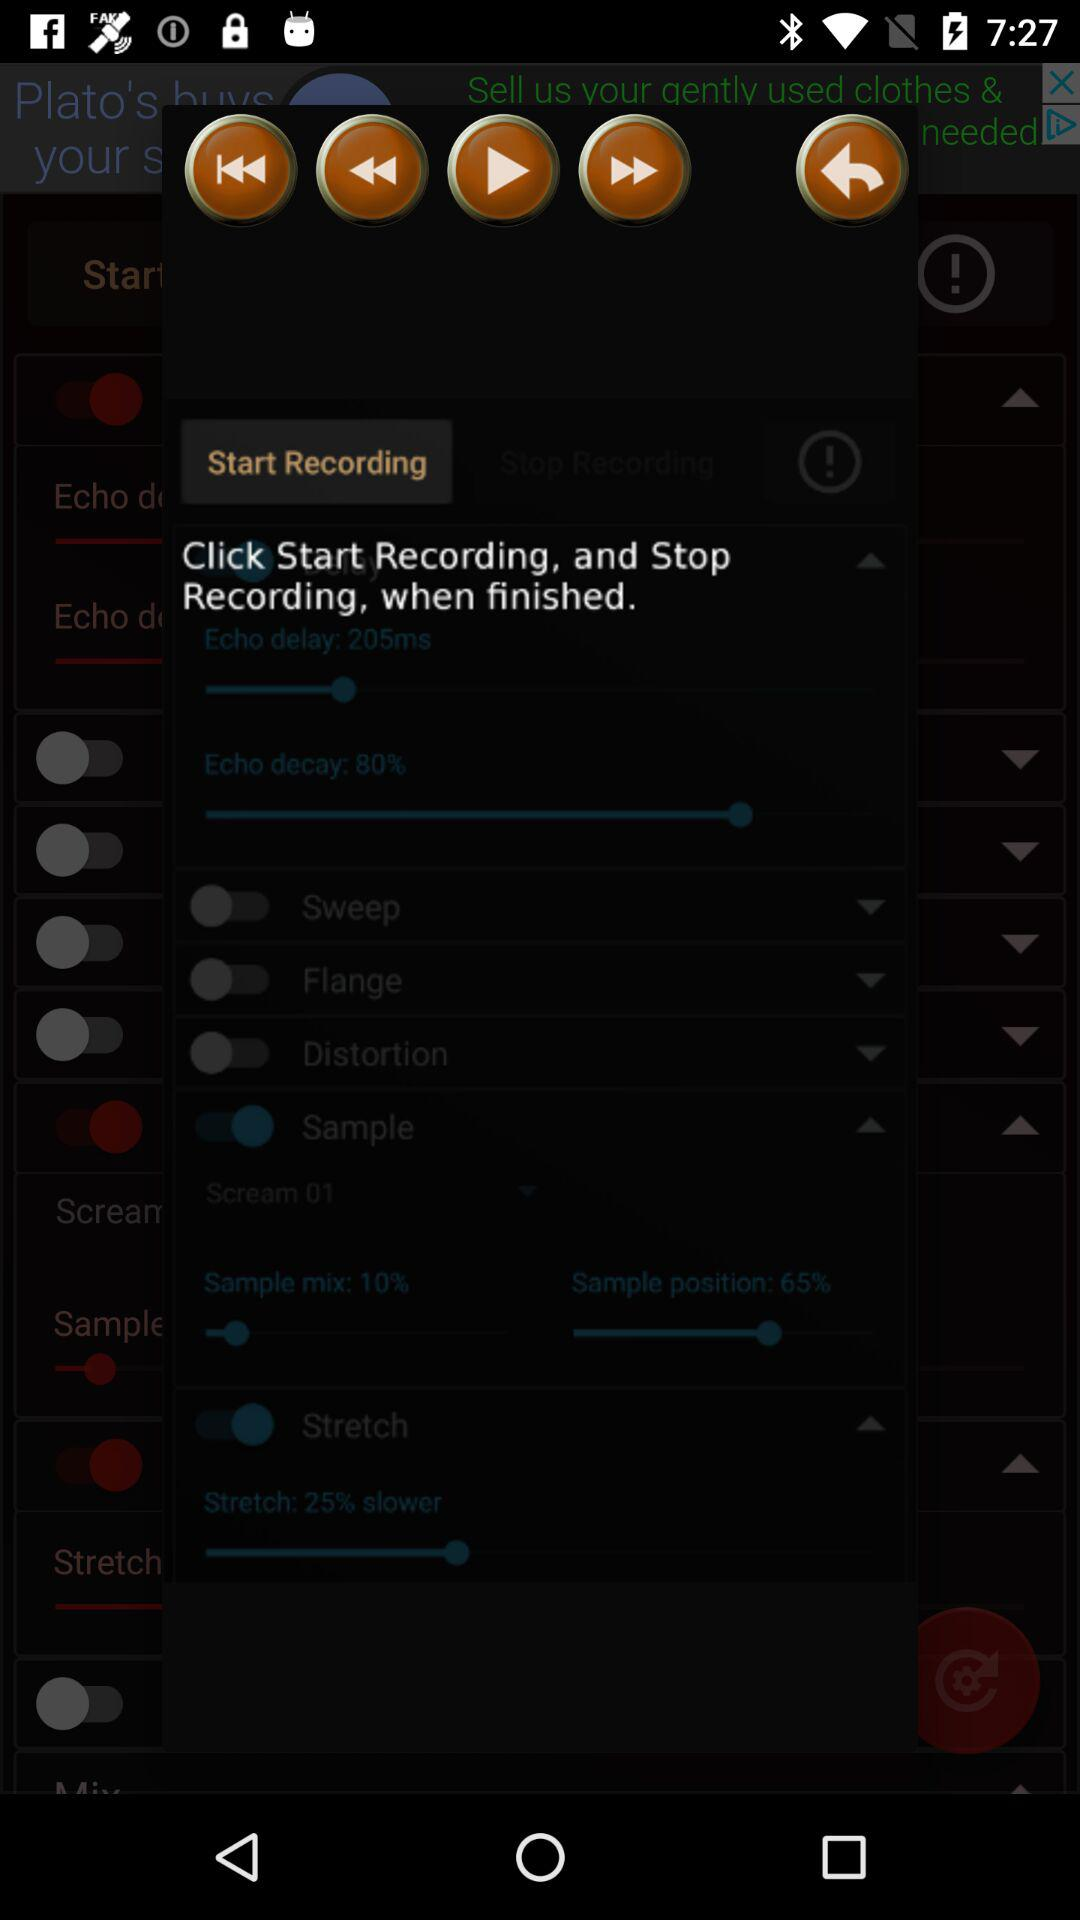What is the echo decay percentile?
When the provided information is insufficient, respond with <no answer>. <no answer> 